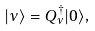<formula> <loc_0><loc_0><loc_500><loc_500>| \nu \rangle = Q _ { \nu } ^ { \dagger } | 0 \rangle ,</formula> 